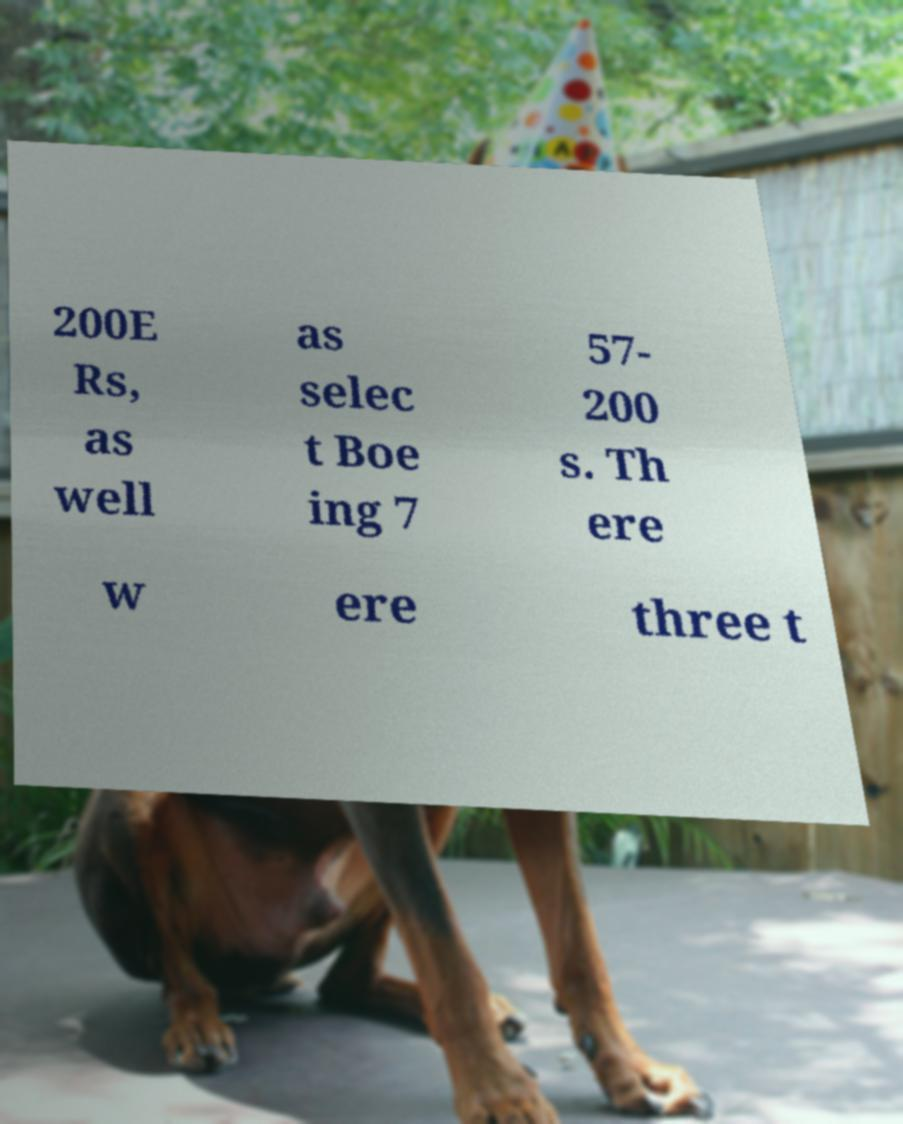Could you assist in decoding the text presented in this image and type it out clearly? 200E Rs, as well as selec t Boe ing 7 57- 200 s. Th ere w ere three t 